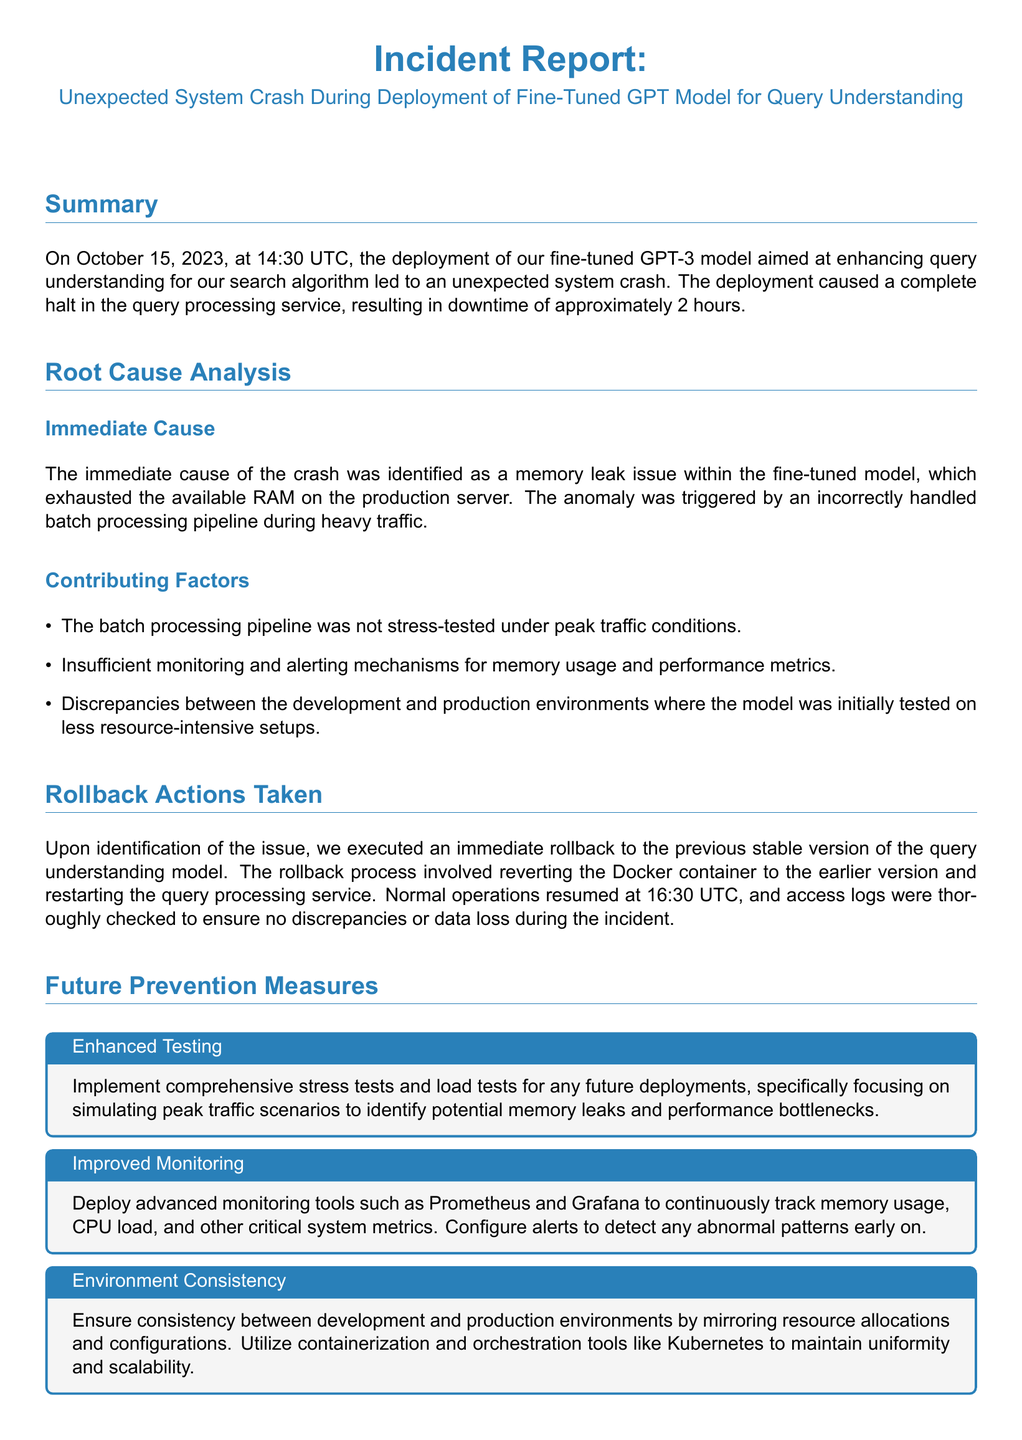What was the date of the incident? The incident date is clearly stated in the summary section of the document.
Answer: October 15, 2023 How long did the system experience downtime? The summary mentions the duration of the downtime directly.
Answer: 2 hours What was the immediate cause of the system crash? The immediate cause is outlined in the root cause analysis section of the document.
Answer: Memory leak issue What action was taken after identifying the issue? The rollback actions section describes the response to the incident.
Answer: Rollback to the previous stable version Which monitoring tools are suggested for future prevention? Future prevention measures identify specific tools recommended for monitoring.
Answer: Prometheus and Grafana What was one of the contributing factors to the incident? The contributing factors section lists issues that led to the crash.
Answer: Lack of stress testing What is a key method suggested for ensuring environment consistency? The future prevention measures address maintaining uniformity across environments.
Answer: Containerization and orchestration tools What should be conducted periodically according to the document? The future prevention measures explicitly recommend a specific type of action.
Answer: Regular audits 